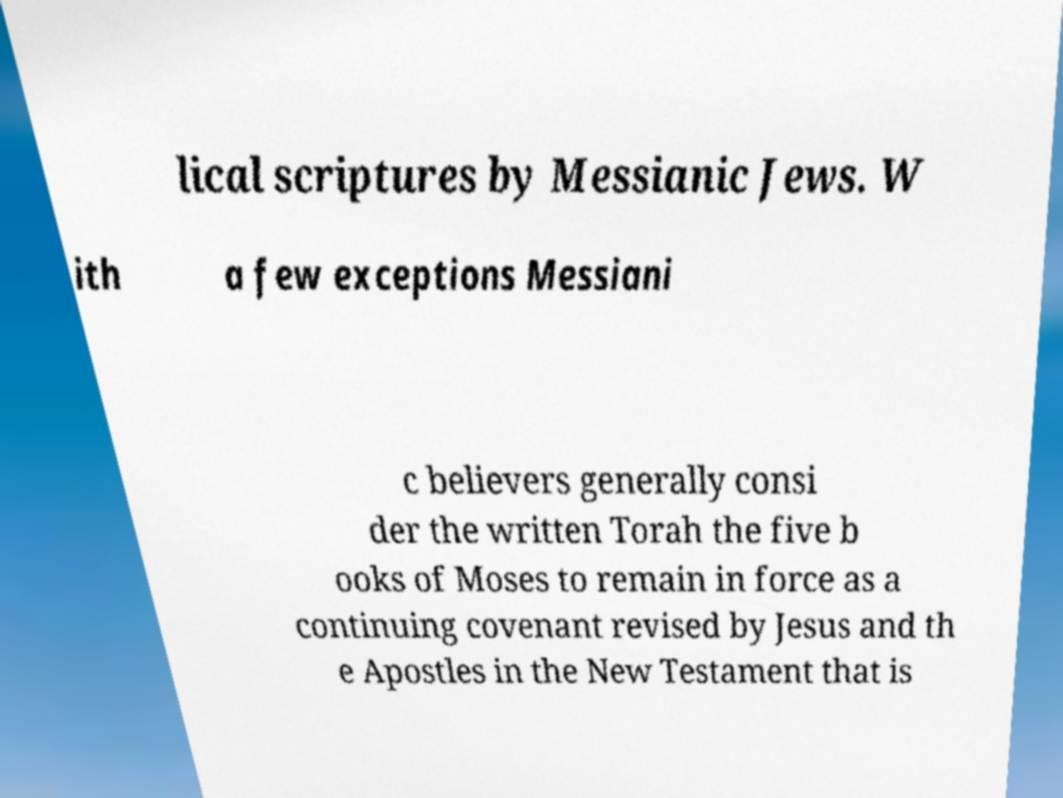Can you read and provide the text displayed in the image?This photo seems to have some interesting text. Can you extract and type it out for me? lical scriptures by Messianic Jews. W ith a few exceptions Messiani c believers generally consi der the written Torah the five b ooks of Moses to remain in force as a continuing covenant revised by Jesus and th e Apostles in the New Testament that is 